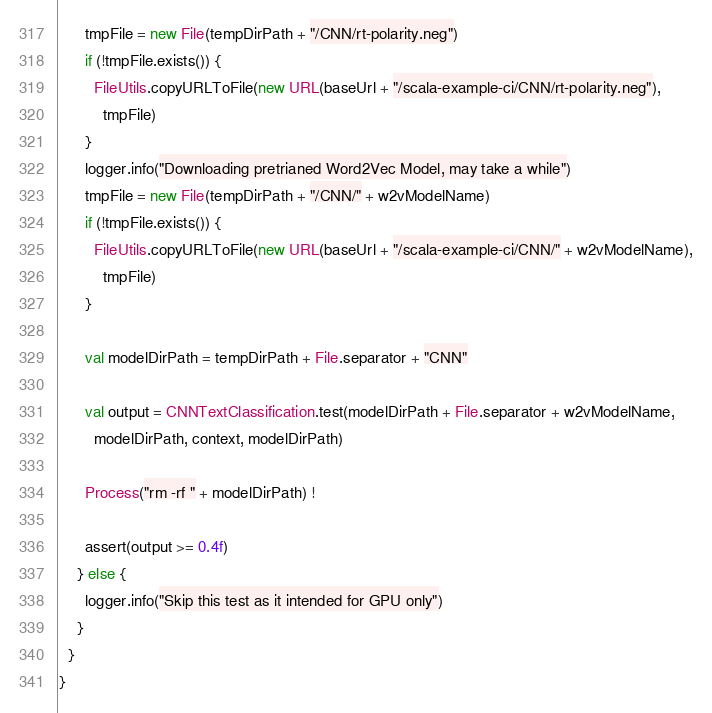<code> <loc_0><loc_0><loc_500><loc_500><_Scala_>      tmpFile = new File(tempDirPath + "/CNN/rt-polarity.neg")
      if (!tmpFile.exists()) {
        FileUtils.copyURLToFile(new URL(baseUrl + "/scala-example-ci/CNN/rt-polarity.neg"),
          tmpFile)
      }
      logger.info("Downloading pretrianed Word2Vec Model, may take a while")
      tmpFile = new File(tempDirPath + "/CNN/" + w2vModelName)
      if (!tmpFile.exists()) {
        FileUtils.copyURLToFile(new URL(baseUrl + "/scala-example-ci/CNN/" + w2vModelName),
          tmpFile)
      }

      val modelDirPath = tempDirPath + File.separator + "CNN"

      val output = CNNTextClassification.test(modelDirPath + File.separator + w2vModelName,
        modelDirPath, context, modelDirPath)

      Process("rm -rf " + modelDirPath) !

      assert(output >= 0.4f)
    } else {
      logger.info("Skip this test as it intended for GPU only")
    }
  }
}
</code> 